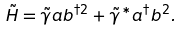<formula> <loc_0><loc_0><loc_500><loc_500>\tilde { H } = \tilde { \gamma } a b ^ { \dag 2 } + \tilde { \gamma } ^ { \ast } a ^ { \dag } b ^ { 2 } .</formula> 